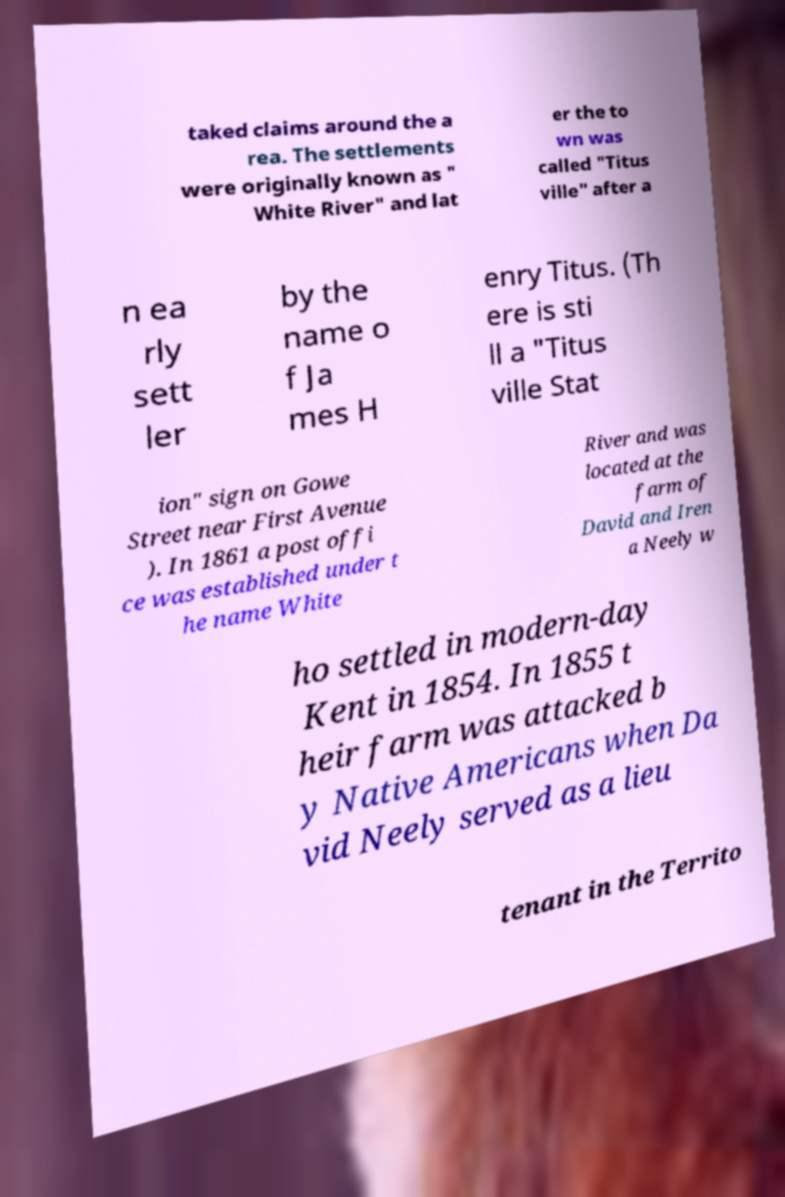Please identify and transcribe the text found in this image. taked claims around the a rea. The settlements were originally known as " White River" and lat er the to wn was called "Titus ville" after a n ea rly sett ler by the name o f Ja mes H enry Titus. (Th ere is sti ll a "Titus ville Stat ion" sign on Gowe Street near First Avenue ). In 1861 a post offi ce was established under t he name White River and was located at the farm of David and Iren a Neely w ho settled in modern-day Kent in 1854. In 1855 t heir farm was attacked b y Native Americans when Da vid Neely served as a lieu tenant in the Territo 